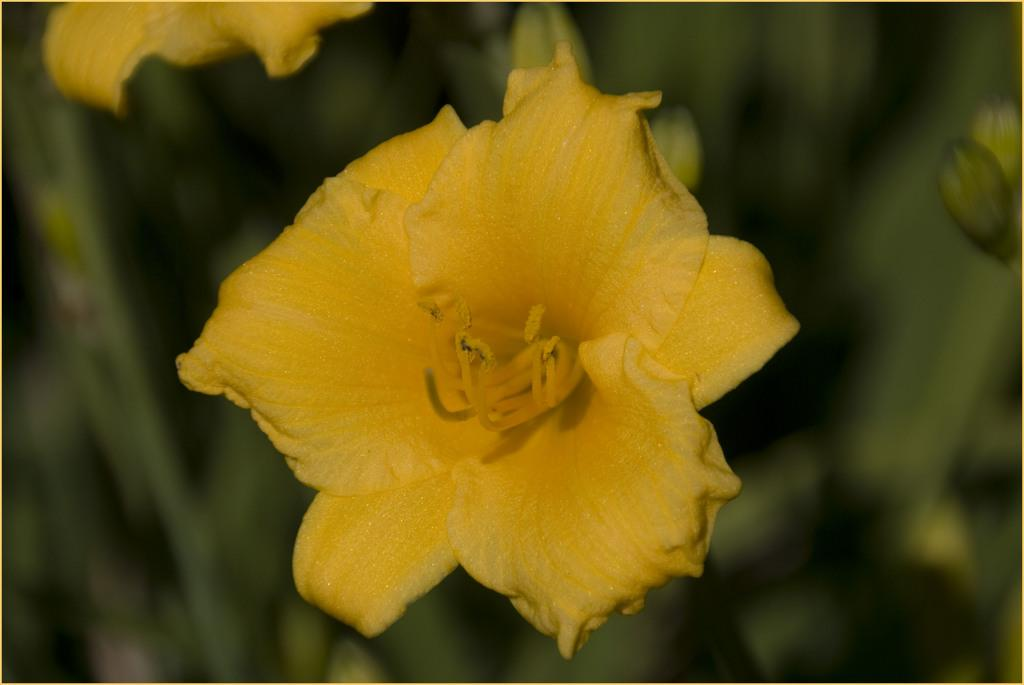What is present in the image? There are flowers in the image. Can you describe the background of the image? The background of the image is blurry. What type of chess piece can be seen in the image? There is no chess piece present in the image; it only features flowers. What is the view from the base of the flowers in the image? The image does not provide a view from the base of the flowers, as it only shows the flowers themselves and a blurry background. 